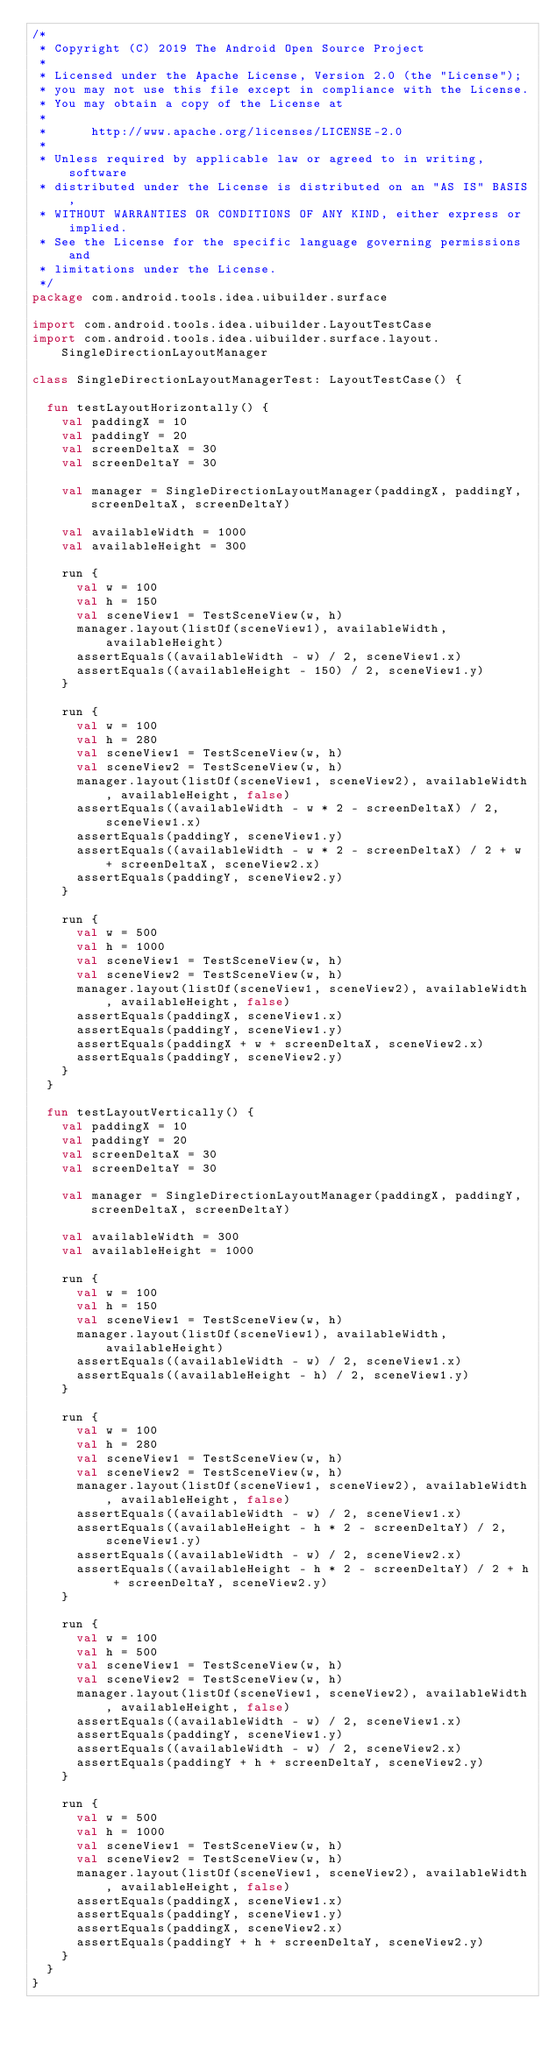<code> <loc_0><loc_0><loc_500><loc_500><_Kotlin_>/*
 * Copyright (C) 2019 The Android Open Source Project
 *
 * Licensed under the Apache License, Version 2.0 (the "License");
 * you may not use this file except in compliance with the License.
 * You may obtain a copy of the License at
 *
 *      http://www.apache.org/licenses/LICENSE-2.0
 *
 * Unless required by applicable law or agreed to in writing, software
 * distributed under the License is distributed on an "AS IS" BASIS,
 * WITHOUT WARRANTIES OR CONDITIONS OF ANY KIND, either express or implied.
 * See the License for the specific language governing permissions and
 * limitations under the License.
 */
package com.android.tools.idea.uibuilder.surface

import com.android.tools.idea.uibuilder.LayoutTestCase
import com.android.tools.idea.uibuilder.surface.layout.SingleDirectionLayoutManager

class SingleDirectionLayoutManagerTest: LayoutTestCase() {

  fun testLayoutHorizontally() {
    val paddingX = 10
    val paddingY = 20
    val screenDeltaX = 30
    val screenDeltaY = 30

    val manager = SingleDirectionLayoutManager(paddingX, paddingY, screenDeltaX, screenDeltaY)

    val availableWidth = 1000
    val availableHeight = 300

    run {
      val w = 100
      val h = 150
      val sceneView1 = TestSceneView(w, h)
      manager.layout(listOf(sceneView1), availableWidth, availableHeight)
      assertEquals((availableWidth - w) / 2, sceneView1.x)
      assertEquals((availableHeight - 150) / 2, sceneView1.y)
    }

    run {
      val w = 100
      val h = 280
      val sceneView1 = TestSceneView(w, h)
      val sceneView2 = TestSceneView(w, h)
      manager.layout(listOf(sceneView1, sceneView2), availableWidth, availableHeight, false)
      assertEquals((availableWidth - w * 2 - screenDeltaX) / 2, sceneView1.x)
      assertEquals(paddingY, sceneView1.y)
      assertEquals((availableWidth - w * 2 - screenDeltaX) / 2 + w + screenDeltaX, sceneView2.x)
      assertEquals(paddingY, sceneView2.y)
    }

    run {
      val w = 500
      val h = 1000
      val sceneView1 = TestSceneView(w, h)
      val sceneView2 = TestSceneView(w, h)
      manager.layout(listOf(sceneView1, sceneView2), availableWidth, availableHeight, false)
      assertEquals(paddingX, sceneView1.x)
      assertEquals(paddingY, sceneView1.y)
      assertEquals(paddingX + w + screenDeltaX, sceneView2.x)
      assertEquals(paddingY, sceneView2.y)
    }
  }

  fun testLayoutVertically() {
    val paddingX = 10
    val paddingY = 20
    val screenDeltaX = 30
    val screenDeltaY = 30

    val manager = SingleDirectionLayoutManager(paddingX, paddingY, screenDeltaX, screenDeltaY)

    val availableWidth = 300
    val availableHeight = 1000

    run {
      val w = 100
      val h = 150
      val sceneView1 = TestSceneView(w, h)
      manager.layout(listOf(sceneView1), availableWidth, availableHeight)
      assertEquals((availableWidth - w) / 2, sceneView1.x)
      assertEquals((availableHeight - h) / 2, sceneView1.y)
    }

    run {
      val w = 100
      val h = 280
      val sceneView1 = TestSceneView(w, h)
      val sceneView2 = TestSceneView(w, h)
      manager.layout(listOf(sceneView1, sceneView2), availableWidth, availableHeight, false)
      assertEquals((availableWidth - w) / 2, sceneView1.x)
      assertEquals((availableHeight - h * 2 - screenDeltaY) / 2, sceneView1.y)
      assertEquals((availableWidth - w) / 2, sceneView2.x)
      assertEquals((availableHeight - h * 2 - screenDeltaY) / 2 + h + screenDeltaY, sceneView2.y)
    }

    run {
      val w = 100
      val h = 500
      val sceneView1 = TestSceneView(w, h)
      val sceneView2 = TestSceneView(w, h)
      manager.layout(listOf(sceneView1, sceneView2), availableWidth, availableHeight, false)
      assertEquals((availableWidth - w) / 2, sceneView1.x)
      assertEquals(paddingY, sceneView1.y)
      assertEquals((availableWidth - w) / 2, sceneView2.x)
      assertEquals(paddingY + h + screenDeltaY, sceneView2.y)
    }

    run {
      val w = 500
      val h = 1000
      val sceneView1 = TestSceneView(w, h)
      val sceneView2 = TestSceneView(w, h)
      manager.layout(listOf(sceneView1, sceneView2), availableWidth, availableHeight, false)
      assertEquals(paddingX, sceneView1.x)
      assertEquals(paddingY, sceneView1.y)
      assertEquals(paddingX, sceneView2.x)
      assertEquals(paddingY + h + screenDeltaY, sceneView2.y)
    }
  }
}
</code> 